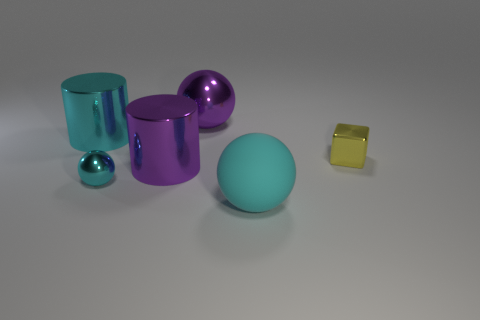How many objects in the image have a reflective surface? All the objects in the image have reflective surfaces, varying from a high-gloss finish to a subdued sheen, contributing to the appearance of a clean and polished arrangement. 